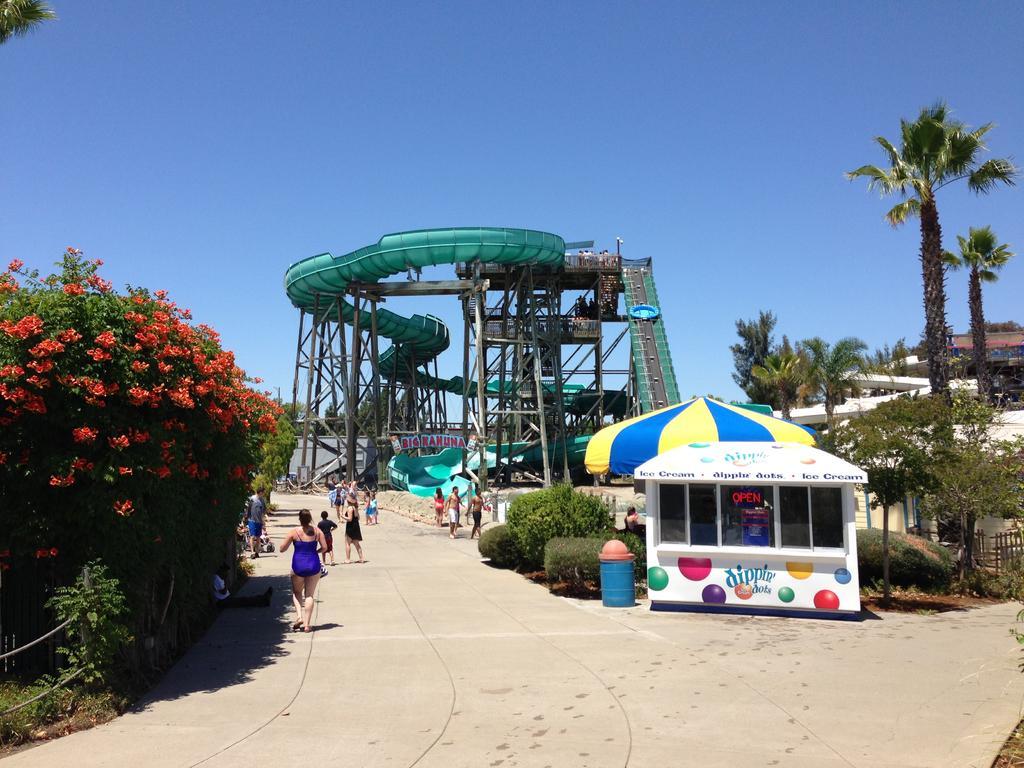How would you summarize this image in a sentence or two? In this image we can see one building, one big water coaster, some iron rods, two fences, one person sitting, one banner with text, some people are walking on the road, one tent, one shop with text, some people are holding objects, some plants with flowers, some objects on the surface, one dustbin, some trees, bushes, plants and grass on the surface. At the top there is the sky. 